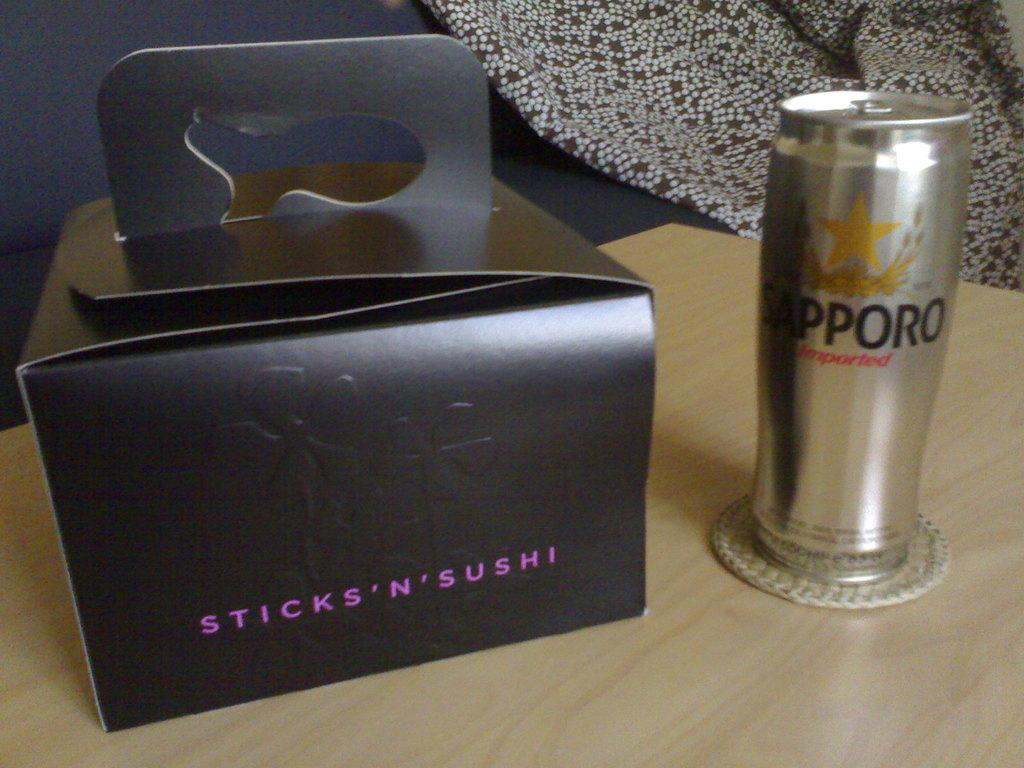<image>
Offer a succinct explanation of the picture presented. Sticks 'n' sushi written on a black box with a silver can on right and the letter Sapporo on it. 